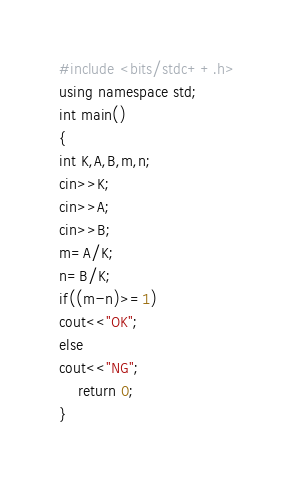<code> <loc_0><loc_0><loc_500><loc_500><_C++_>#include <bits/stdc++.h> 
using namespace std;
int main()
{
int K,A,B,m,n;
cin>>K;
cin>>A;
cin>>B;
m=A/K;
n=B/K;
if((m-n)>=1)
cout<<"OK";
else
cout<<"NG";
    return 0;
}</code> 